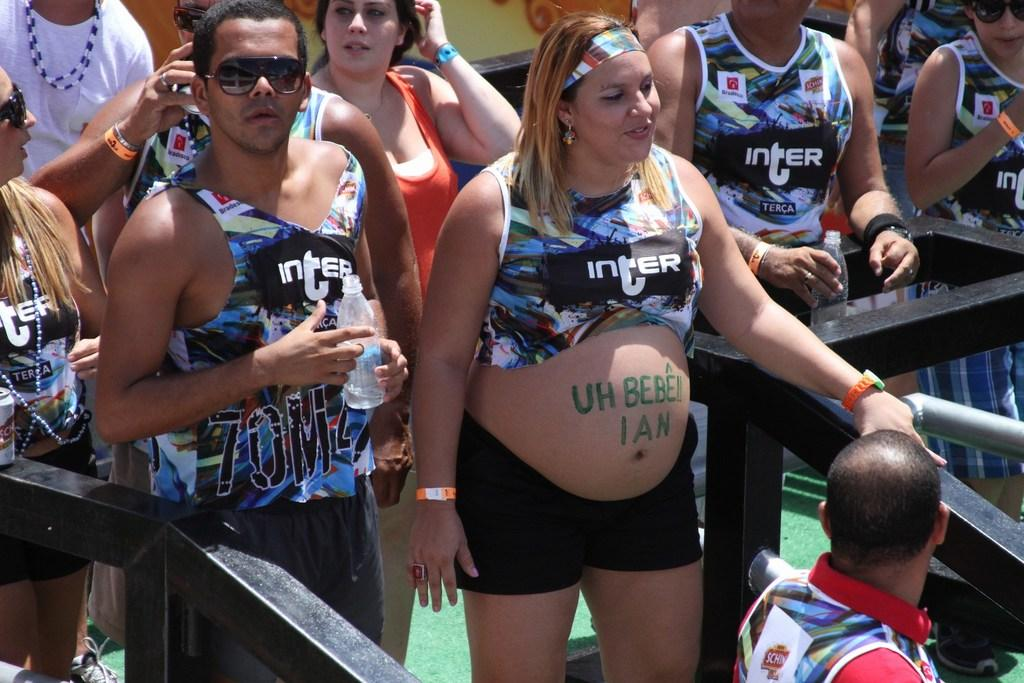<image>
Summarize the visual content of the image. the runners are wearing multiple colors Inter tops 